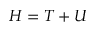Convert formula to latex. <formula><loc_0><loc_0><loc_500><loc_500>H = T + U</formula> 